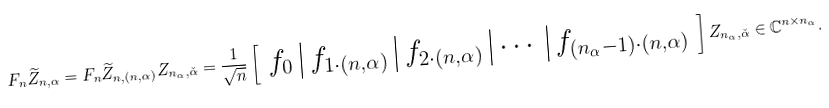<formula> <loc_0><loc_0><loc_500><loc_500>F _ { n } \widetilde { Z } _ { n , \alpha } = F _ { n } \widetilde { Z } _ { n , ( n , \alpha ) } Z _ { n _ { \alpha } , \check { \alpha } } = \frac { 1 } { \sqrt { n } } \left [ \begin{array} { c | c | c | c | c } f _ { 0 } & f _ { 1 \cdot ( n , \alpha ) } & f _ { 2 \cdot ( n , \alpha ) } & \cdots & f _ { ( n _ { \alpha } - 1 ) \cdot ( n , \alpha ) } \end{array} \right ] Z _ { n _ { \alpha } , \check { \alpha } } \in \mathbb { C } ^ { n \times n _ { \alpha } } .</formula> 